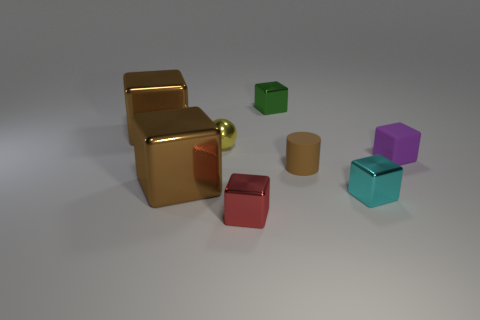How many other things are there of the same material as the yellow thing?
Offer a very short reply. 5. There is a tiny metallic thing on the right side of the tiny metallic block that is behind the ball; what shape is it?
Provide a succinct answer. Cube. How many things are big green shiny cylinders or tiny rubber objects to the left of the cyan metal cube?
Your response must be concise. 1. What number of other things are there of the same color as the ball?
Offer a very short reply. 0. How many gray objects are either metal objects or large blocks?
Your answer should be very brief. 0. Are there any small spheres right of the tiny metal object that is on the right side of the small metallic cube that is behind the small yellow shiny thing?
Offer a terse response. No. Are there any other things that are the same size as the red metallic thing?
Offer a terse response. Yes. There is a large shiny thing that is behind the brown thing that is to the right of the tiny green cube; what is its color?
Offer a very short reply. Brown. What number of large things are either brown shiny cubes or red shiny objects?
Your response must be concise. 2. There is a tiny cube that is both behind the cyan metallic block and left of the cyan thing; what is its color?
Your answer should be compact. Green. 